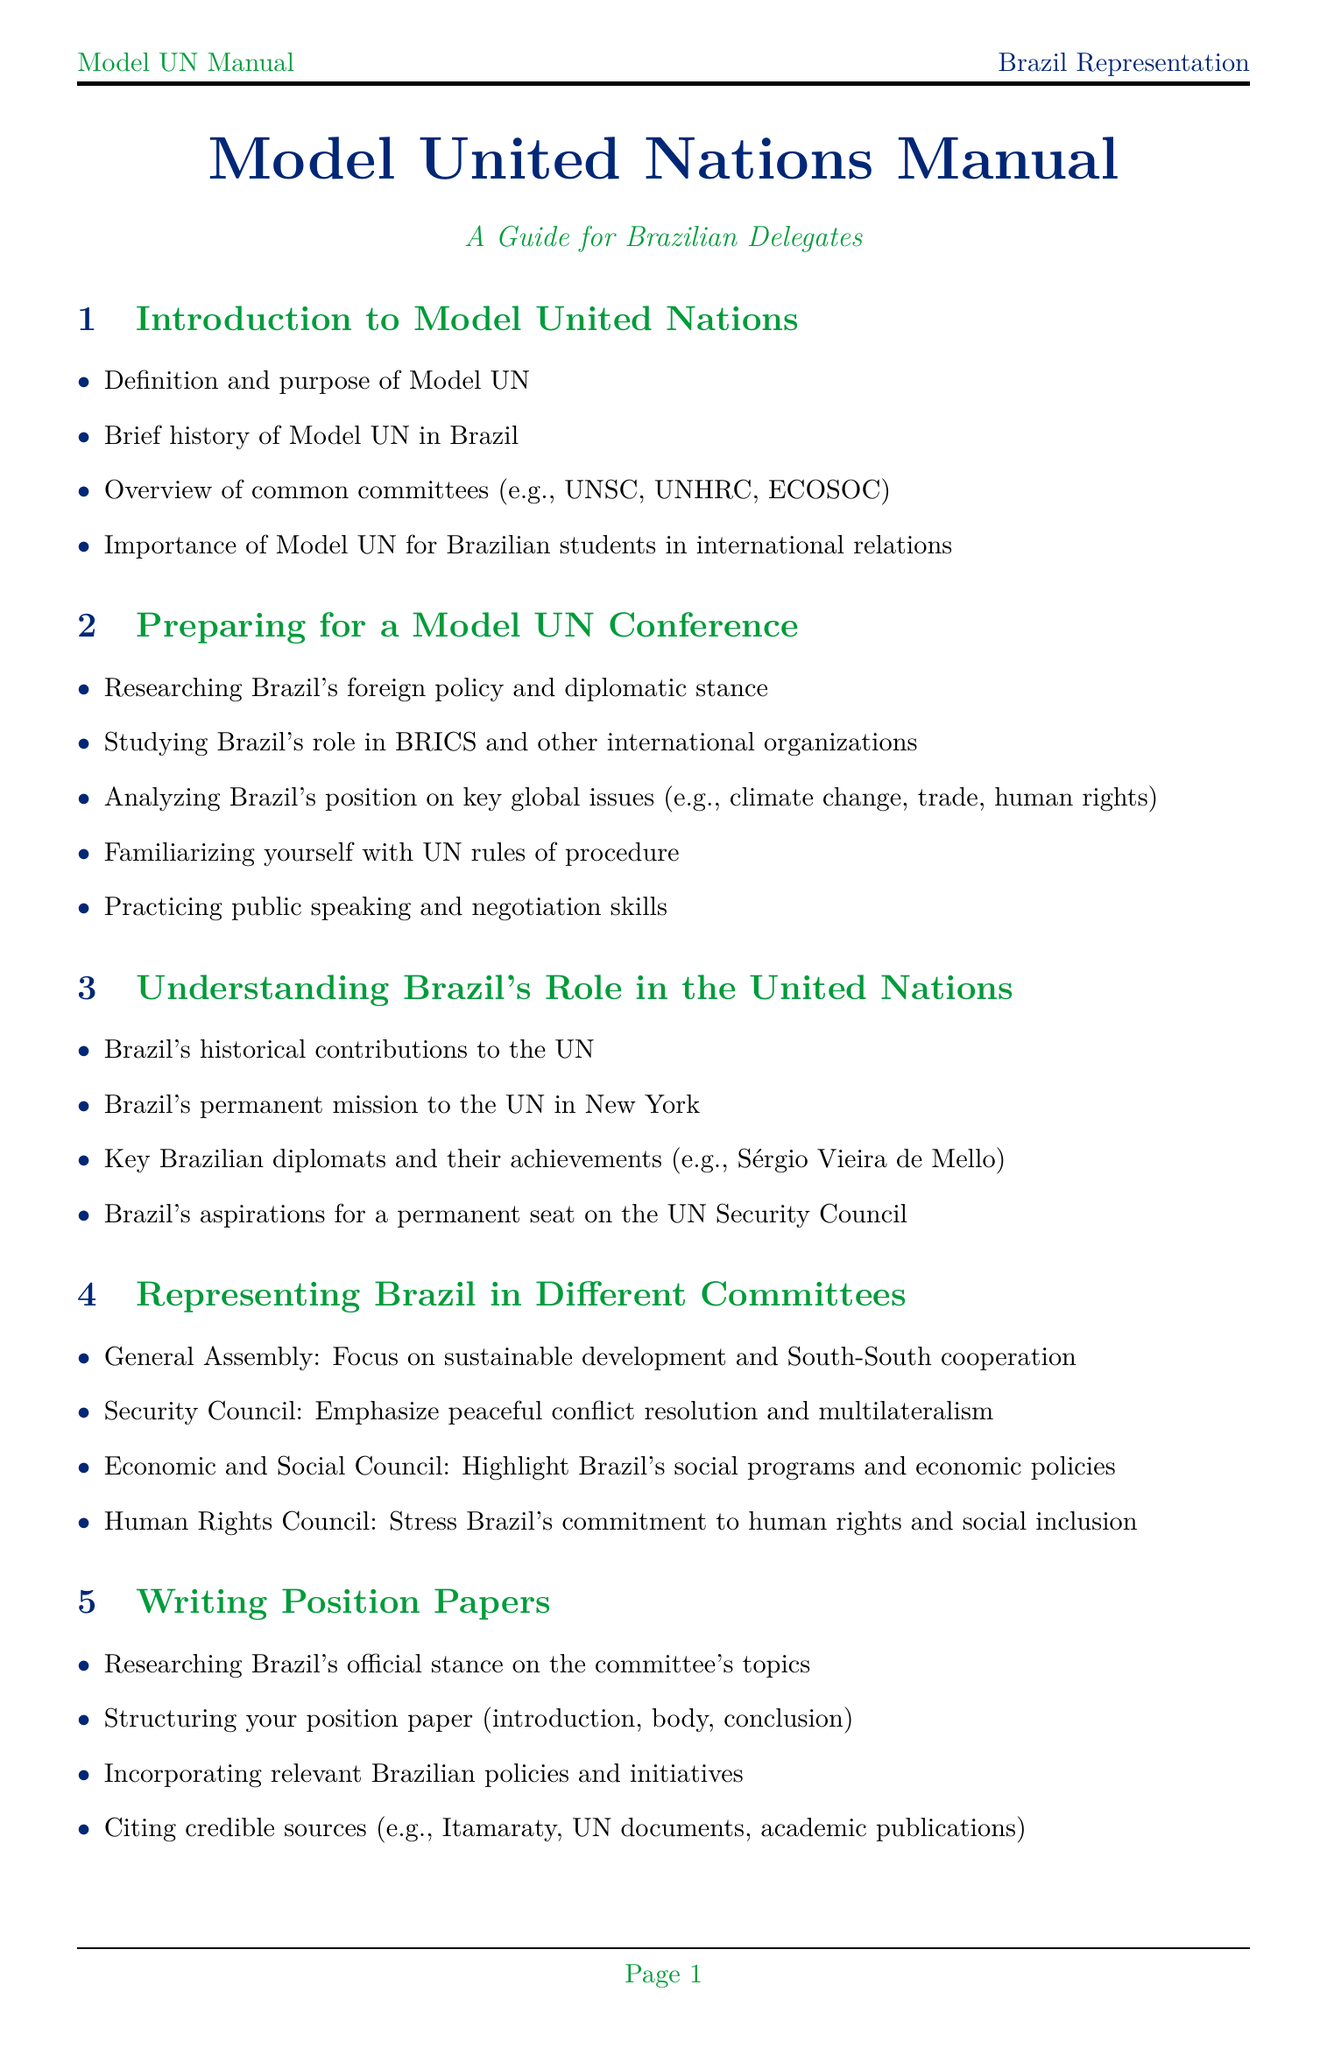What is the purpose of Model UN? The purpose of Model UN is a key concept introduced in the manual, defining its role in simulating the work of the United Nations.
Answer: Definition and purpose of Model UN Who is a key Brazilian diplomat mentioned in the document? The manual highlights significant figures in Brazilian diplomacy, including their contributions.
Answer: Sérgio Vieira de Mello What is Brazil's main focus in the General Assembly? The manual specifies key issues that Brazil should address when participating in the General Assembly.
Answer: Sustainable development and South-South cooperation What is Brazil's aspiration regarding the UN Security Council? The manual outlines Brazil's goals related to its status within international governance institutions.
Answer: A permanent seat Which Brazilian institution focuses on foreign affairs? The manual lists key institutions relevant to Brazil's international relations.
Answer: Ministry of Foreign Affairs (Itamaraty) What is one major document recommended for reading? The manual provides a section suggesting important readings related to Brazilian foreign policy.
Answer: Brazilian Foreign Policy after the Cold War What key global issue should Brazil analyze? The manual identifies specific global challenges that Brazilian delegates need to understand.
Answer: Climate change How should Brazilian delegates respond to criticism of policies? The manual advises on handling challenging situations, particularly regarding Brazil's policies.
Answer: Responding to criticism of Brazil's policies What does Brazil emphasize in economic and social council? The manual outlines Brazil’s approach to different UN committees regarding social issues.
Answer: Brazil's social programs and economic policies 